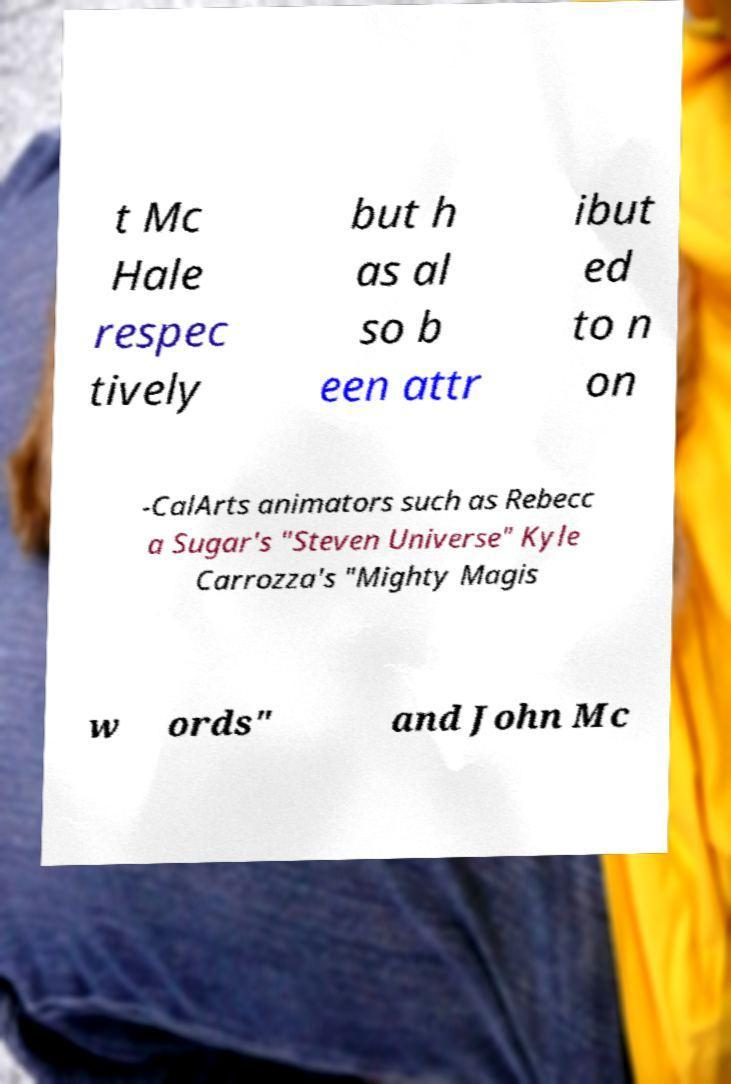Could you assist in decoding the text presented in this image and type it out clearly? t Mc Hale respec tively but h as al so b een attr ibut ed to n on -CalArts animators such as Rebecc a Sugar's "Steven Universe" Kyle Carrozza's "Mighty Magis w ords" and John Mc 